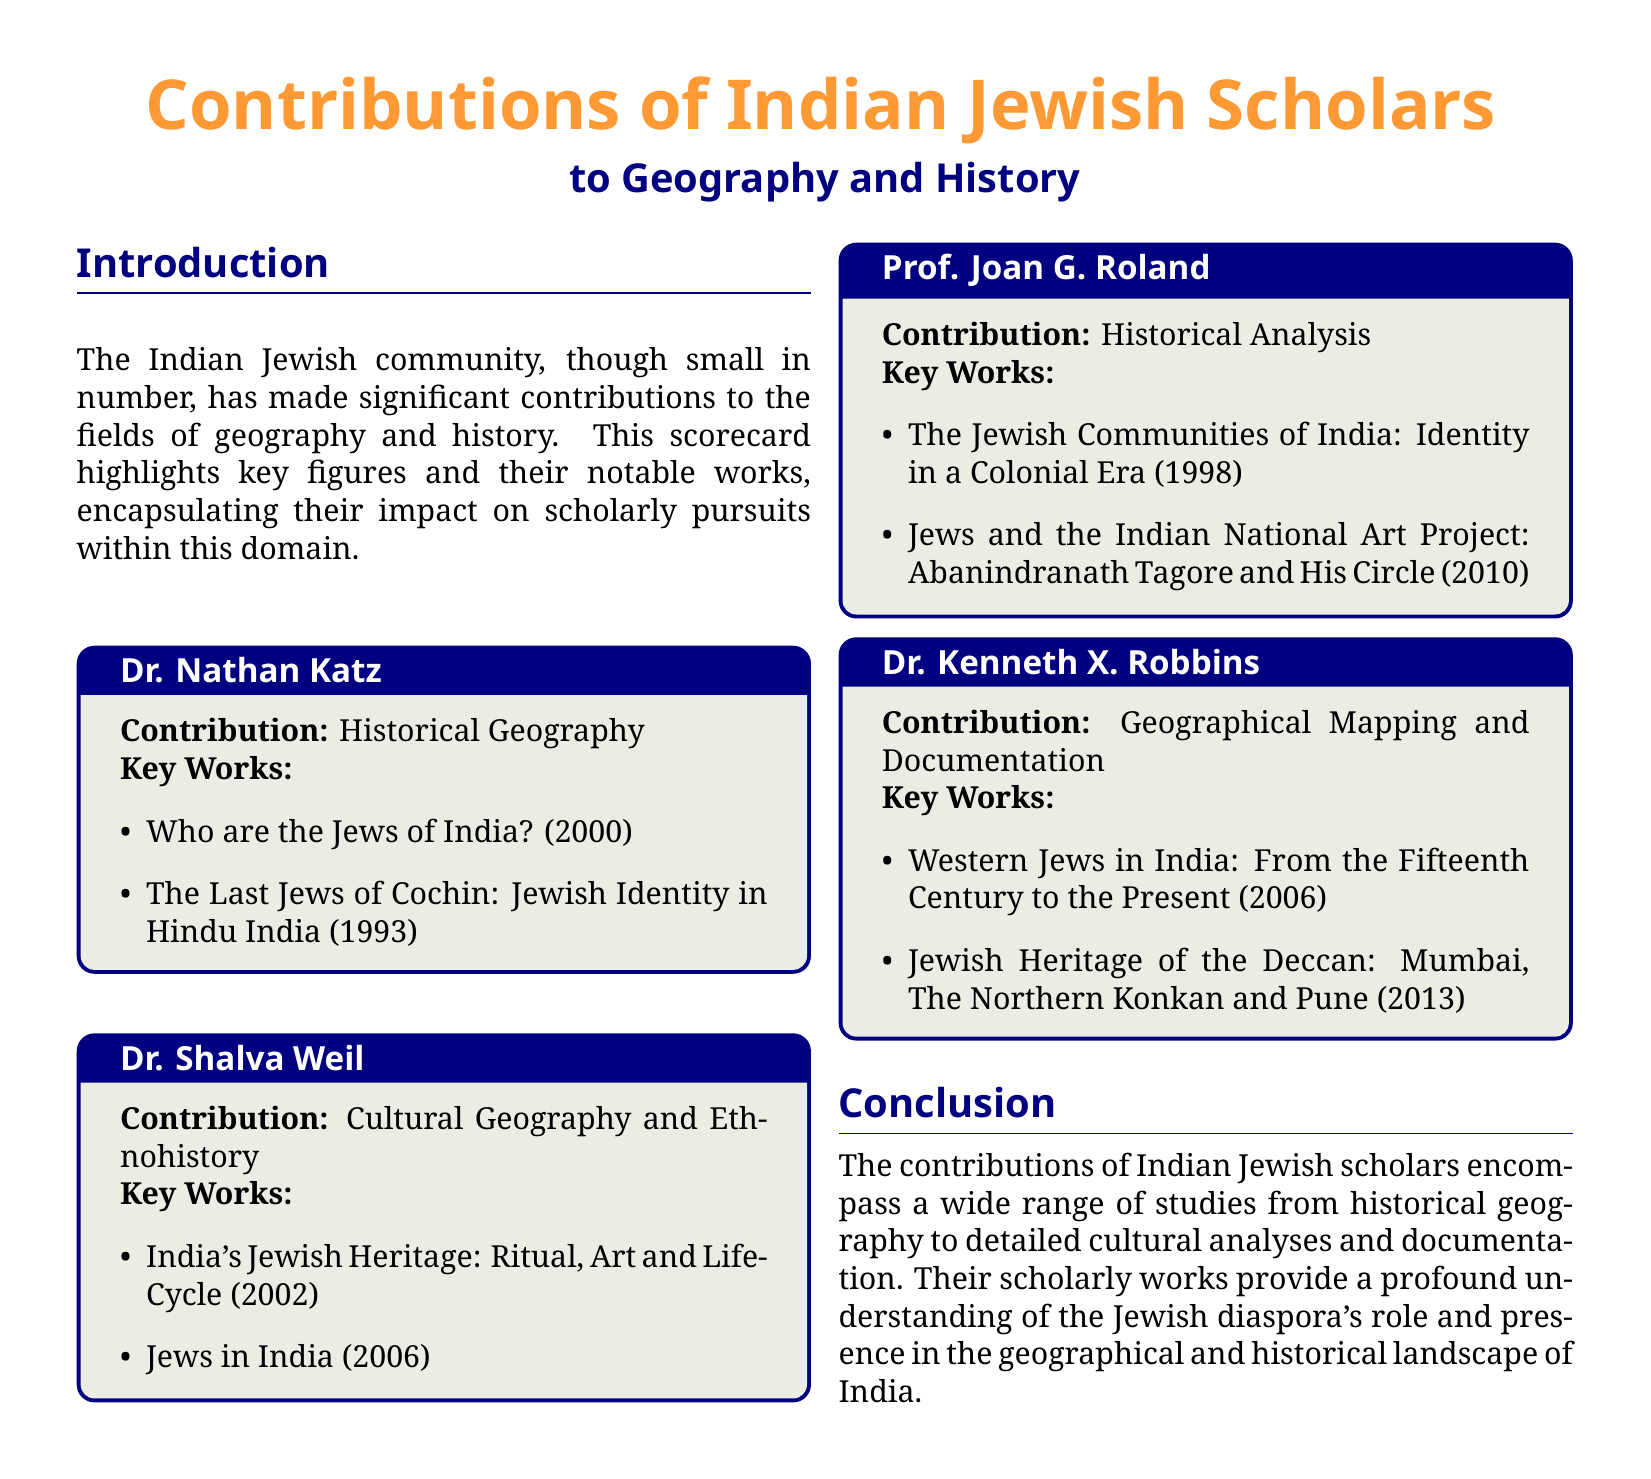What is the focus area of Dr. Nathan Katz? Dr. Nathan Katz specializes in Historical Geography, as mentioned in the document.
Answer: Historical Geography What year was "India's Jewish Heritage: Ritual, Art and Life-Cycle" published? The publication year of the work is explicitly stated in the document.
Answer: 2002 Who authored "The Jewish Communities of India: Identity in a Colonial Era"? The document lists Prof. Joan G. Roland as the author of this specific work.
Answer: Prof. Joan G. Roland In which field does Dr. Kenneth X. Robbins contribute? Dr. Kenneth X. Robbins is noted for his contributions in Geographical Mapping and Documentation.
Answer: Geographical Mapping and Documentation How many works are attributed to Dr. Shalva Weil in the document? The document lists two key works under Dr. Shalva Weil's contributions.
Answer: 2 What is the main theme of the scorecard? The document emphasizes contributions to Geography and History, particularly by Indian Jewish scholars.
Answer: Contributions to Geography and History Which scholar worked on the "Last Jews of Cochin"? The document specifies that Dr. Nathan Katz is the scholar associated with this work.
Answer: Dr. Nathan Katz What is the publication year of "Jews in India"? The document provides the year of publication for this work as part of Dr. Shalva Weil's contributions.
Answer: 2006 What type of document is this? The structure and content of the document indicate that it is a scorecard highlighting contributions and key figures.
Answer: Scorecard 